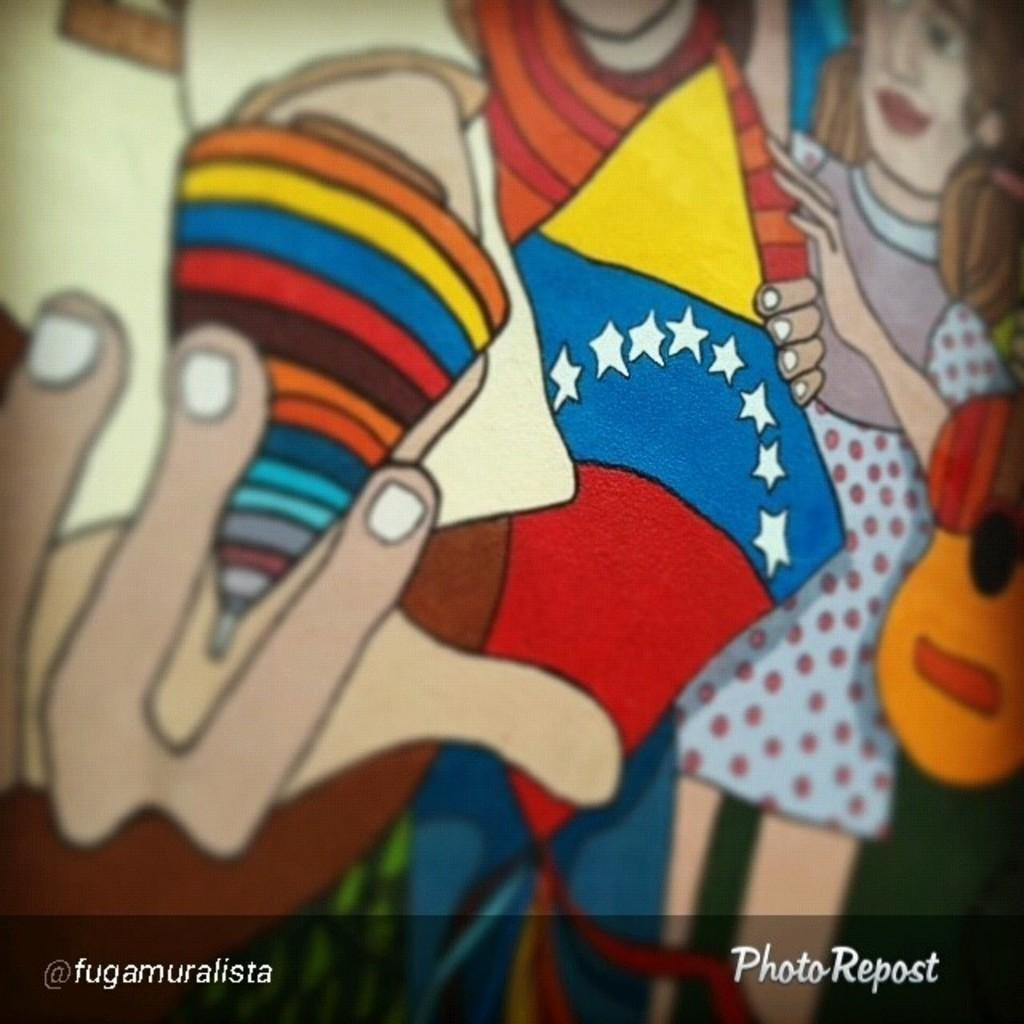What type of objects are in the image? There are cartoon toys in the image. Can you describe the appearance of the toys? The toys are in different colors. Is there any text present in the image? Yes, there is text written at the bottom of the image. What type of bait is being used by the boy in the image? There is no boy or bait present in the image; it features cartoon toys and text. What type of crown is the queen wearing in the image? There is no queen or crown present in the image; it features cartoon toys and text. 